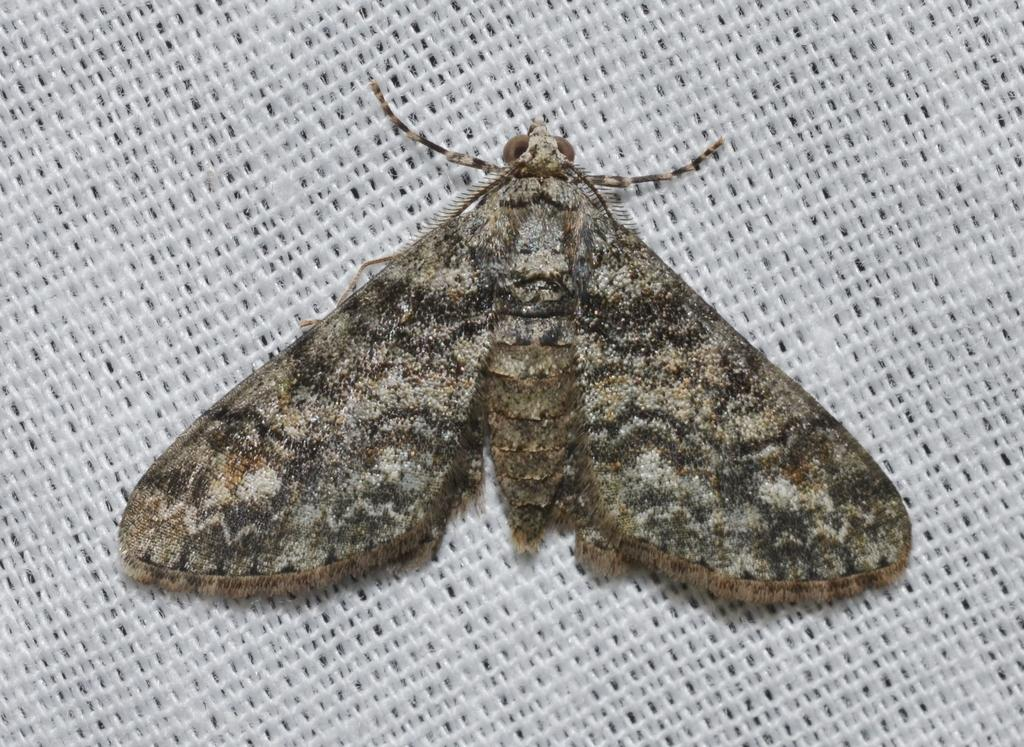What is the main subject of the image? There is a butterfly in the image. Where is the butterfly located in the image? The butterfly is in the center of the image. What is the color of the surface on which the butterfly is resting? The butterfly is on a white color surface. What scent does the butterfly emit in the image? Butterflies do not emit scents, and there is no indication of any scent in the image. 